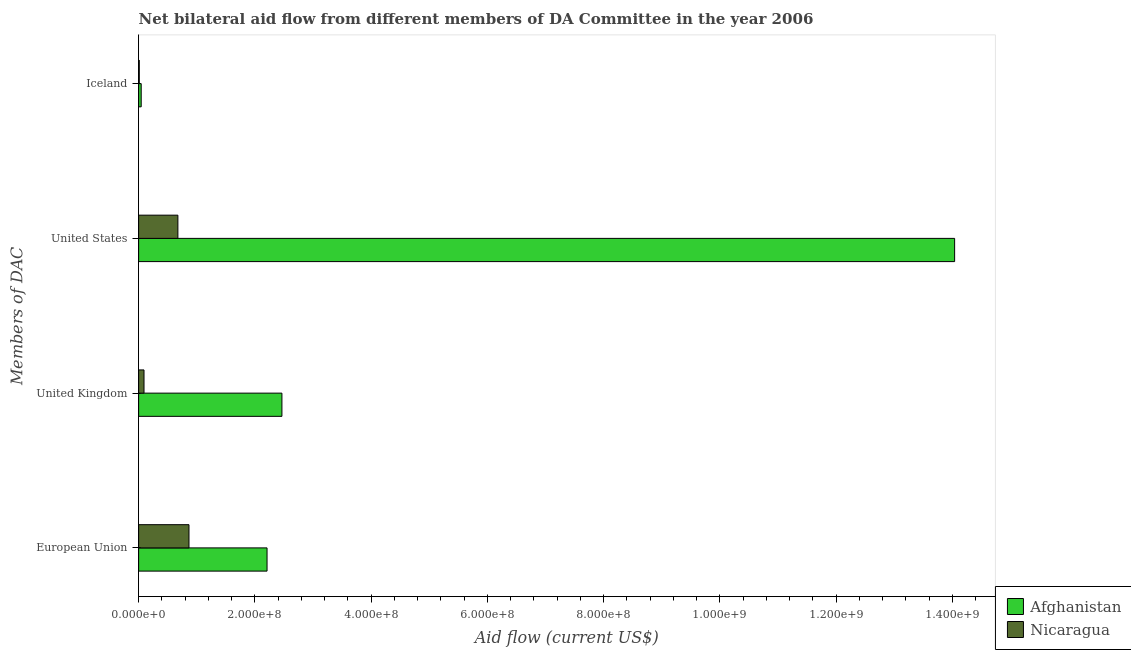How many groups of bars are there?
Keep it short and to the point. 4. How many bars are there on the 1st tick from the bottom?
Provide a short and direct response. 2. What is the amount of aid given by us in Nicaragua?
Your answer should be compact. 6.75e+07. Across all countries, what is the maximum amount of aid given by eu?
Provide a short and direct response. 2.21e+08. Across all countries, what is the minimum amount of aid given by uk?
Make the answer very short. 9.26e+06. In which country was the amount of aid given by uk maximum?
Offer a terse response. Afghanistan. In which country was the amount of aid given by us minimum?
Your answer should be compact. Nicaragua. What is the total amount of aid given by us in the graph?
Make the answer very short. 1.47e+09. What is the difference between the amount of aid given by iceland in Nicaragua and that in Afghanistan?
Ensure brevity in your answer.  -3.29e+06. What is the difference between the amount of aid given by iceland in Afghanistan and the amount of aid given by us in Nicaragua?
Your response must be concise. -6.31e+07. What is the average amount of aid given by iceland per country?
Give a very brief answer. 2.78e+06. What is the difference between the amount of aid given by eu and amount of aid given by iceland in Nicaragua?
Offer a terse response. 8.55e+07. In how many countries, is the amount of aid given by eu greater than 1160000000 US$?
Offer a very short reply. 0. What is the ratio of the amount of aid given by eu in Afghanistan to that in Nicaragua?
Your answer should be very brief. 2.55. Is the amount of aid given by us in Afghanistan less than that in Nicaragua?
Make the answer very short. No. What is the difference between the highest and the second highest amount of aid given by iceland?
Offer a terse response. 3.29e+06. What is the difference between the highest and the lowest amount of aid given by iceland?
Make the answer very short. 3.29e+06. In how many countries, is the amount of aid given by uk greater than the average amount of aid given by uk taken over all countries?
Your answer should be compact. 1. What does the 2nd bar from the top in United States represents?
Ensure brevity in your answer.  Afghanistan. What does the 1st bar from the bottom in United Kingdom represents?
Keep it short and to the point. Afghanistan. Is it the case that in every country, the sum of the amount of aid given by eu and amount of aid given by uk is greater than the amount of aid given by us?
Ensure brevity in your answer.  No. How many bars are there?
Your answer should be compact. 8. What is the difference between two consecutive major ticks on the X-axis?
Ensure brevity in your answer.  2.00e+08. Where does the legend appear in the graph?
Make the answer very short. Bottom right. What is the title of the graph?
Keep it short and to the point. Net bilateral aid flow from different members of DA Committee in the year 2006. What is the label or title of the Y-axis?
Provide a short and direct response. Members of DAC. What is the Aid flow (current US$) of Afghanistan in European Union?
Provide a succinct answer. 2.21e+08. What is the Aid flow (current US$) of Nicaragua in European Union?
Offer a very short reply. 8.66e+07. What is the Aid flow (current US$) in Afghanistan in United Kingdom?
Keep it short and to the point. 2.46e+08. What is the Aid flow (current US$) of Nicaragua in United Kingdom?
Provide a short and direct response. 9.26e+06. What is the Aid flow (current US$) of Afghanistan in United States?
Give a very brief answer. 1.40e+09. What is the Aid flow (current US$) in Nicaragua in United States?
Your answer should be compact. 6.75e+07. What is the Aid flow (current US$) in Afghanistan in Iceland?
Offer a very short reply. 4.42e+06. What is the Aid flow (current US$) in Nicaragua in Iceland?
Your response must be concise. 1.13e+06. Across all Members of DAC, what is the maximum Aid flow (current US$) in Afghanistan?
Provide a succinct answer. 1.40e+09. Across all Members of DAC, what is the maximum Aid flow (current US$) in Nicaragua?
Ensure brevity in your answer.  8.66e+07. Across all Members of DAC, what is the minimum Aid flow (current US$) in Afghanistan?
Provide a short and direct response. 4.42e+06. Across all Members of DAC, what is the minimum Aid flow (current US$) in Nicaragua?
Ensure brevity in your answer.  1.13e+06. What is the total Aid flow (current US$) in Afghanistan in the graph?
Give a very brief answer. 1.88e+09. What is the total Aid flow (current US$) of Nicaragua in the graph?
Keep it short and to the point. 1.65e+08. What is the difference between the Aid flow (current US$) in Afghanistan in European Union and that in United Kingdom?
Provide a succinct answer. -2.56e+07. What is the difference between the Aid flow (current US$) of Nicaragua in European Union and that in United Kingdom?
Give a very brief answer. 7.74e+07. What is the difference between the Aid flow (current US$) of Afghanistan in European Union and that in United States?
Make the answer very short. -1.18e+09. What is the difference between the Aid flow (current US$) in Nicaragua in European Union and that in United States?
Your answer should be compact. 1.91e+07. What is the difference between the Aid flow (current US$) in Afghanistan in European Union and that in Iceland?
Give a very brief answer. 2.16e+08. What is the difference between the Aid flow (current US$) in Nicaragua in European Union and that in Iceland?
Provide a short and direct response. 8.55e+07. What is the difference between the Aid flow (current US$) in Afghanistan in United Kingdom and that in United States?
Your answer should be compact. -1.16e+09. What is the difference between the Aid flow (current US$) of Nicaragua in United Kingdom and that in United States?
Your answer should be compact. -5.83e+07. What is the difference between the Aid flow (current US$) of Afghanistan in United Kingdom and that in Iceland?
Offer a very short reply. 2.42e+08. What is the difference between the Aid flow (current US$) of Nicaragua in United Kingdom and that in Iceland?
Your answer should be very brief. 8.13e+06. What is the difference between the Aid flow (current US$) in Afghanistan in United States and that in Iceland?
Your answer should be compact. 1.40e+09. What is the difference between the Aid flow (current US$) of Nicaragua in United States and that in Iceland?
Ensure brevity in your answer.  6.64e+07. What is the difference between the Aid flow (current US$) in Afghanistan in European Union and the Aid flow (current US$) in Nicaragua in United Kingdom?
Make the answer very short. 2.12e+08. What is the difference between the Aid flow (current US$) of Afghanistan in European Union and the Aid flow (current US$) of Nicaragua in United States?
Give a very brief answer. 1.53e+08. What is the difference between the Aid flow (current US$) in Afghanistan in European Union and the Aid flow (current US$) in Nicaragua in Iceland?
Your response must be concise. 2.20e+08. What is the difference between the Aid flow (current US$) in Afghanistan in United Kingdom and the Aid flow (current US$) in Nicaragua in United States?
Give a very brief answer. 1.79e+08. What is the difference between the Aid flow (current US$) in Afghanistan in United Kingdom and the Aid flow (current US$) in Nicaragua in Iceland?
Keep it short and to the point. 2.45e+08. What is the difference between the Aid flow (current US$) of Afghanistan in United States and the Aid flow (current US$) of Nicaragua in Iceland?
Provide a succinct answer. 1.40e+09. What is the average Aid flow (current US$) of Afghanistan per Members of DAC?
Provide a short and direct response. 4.69e+08. What is the average Aid flow (current US$) in Nicaragua per Members of DAC?
Keep it short and to the point. 4.11e+07. What is the difference between the Aid flow (current US$) in Afghanistan and Aid flow (current US$) in Nicaragua in European Union?
Ensure brevity in your answer.  1.34e+08. What is the difference between the Aid flow (current US$) of Afghanistan and Aid flow (current US$) of Nicaragua in United Kingdom?
Provide a succinct answer. 2.37e+08. What is the difference between the Aid flow (current US$) of Afghanistan and Aid flow (current US$) of Nicaragua in United States?
Your answer should be compact. 1.34e+09. What is the difference between the Aid flow (current US$) in Afghanistan and Aid flow (current US$) in Nicaragua in Iceland?
Keep it short and to the point. 3.29e+06. What is the ratio of the Aid flow (current US$) in Afghanistan in European Union to that in United Kingdom?
Your answer should be very brief. 0.9. What is the ratio of the Aid flow (current US$) in Nicaragua in European Union to that in United Kingdom?
Ensure brevity in your answer.  9.35. What is the ratio of the Aid flow (current US$) in Afghanistan in European Union to that in United States?
Keep it short and to the point. 0.16. What is the ratio of the Aid flow (current US$) in Nicaragua in European Union to that in United States?
Ensure brevity in your answer.  1.28. What is the ratio of the Aid flow (current US$) of Afghanistan in European Union to that in Iceland?
Make the answer very short. 49.98. What is the ratio of the Aid flow (current US$) in Nicaragua in European Union to that in Iceland?
Your response must be concise. 76.65. What is the ratio of the Aid flow (current US$) in Afghanistan in United Kingdom to that in United States?
Keep it short and to the point. 0.18. What is the ratio of the Aid flow (current US$) in Nicaragua in United Kingdom to that in United States?
Keep it short and to the point. 0.14. What is the ratio of the Aid flow (current US$) of Afghanistan in United Kingdom to that in Iceland?
Keep it short and to the point. 55.77. What is the ratio of the Aid flow (current US$) of Nicaragua in United Kingdom to that in Iceland?
Your answer should be very brief. 8.19. What is the ratio of the Aid flow (current US$) of Afghanistan in United States to that in Iceland?
Your response must be concise. 317.58. What is the ratio of the Aid flow (current US$) of Nicaragua in United States to that in Iceland?
Keep it short and to the point. 59.76. What is the difference between the highest and the second highest Aid flow (current US$) in Afghanistan?
Ensure brevity in your answer.  1.16e+09. What is the difference between the highest and the second highest Aid flow (current US$) of Nicaragua?
Give a very brief answer. 1.91e+07. What is the difference between the highest and the lowest Aid flow (current US$) of Afghanistan?
Keep it short and to the point. 1.40e+09. What is the difference between the highest and the lowest Aid flow (current US$) in Nicaragua?
Provide a succinct answer. 8.55e+07. 